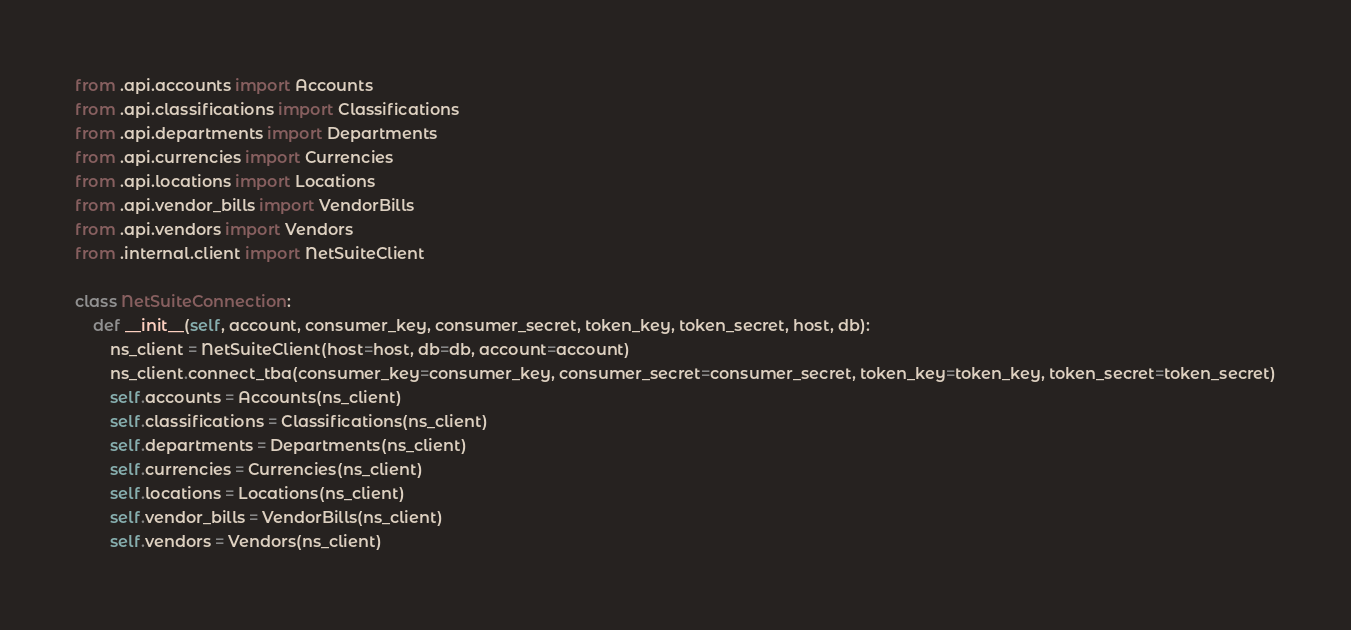<code> <loc_0><loc_0><loc_500><loc_500><_Python_>from .api.accounts import Accounts
from .api.classifications import Classifications
from .api.departments import Departments
from .api.currencies import Currencies
from .api.locations import Locations
from .api.vendor_bills import VendorBills
from .api.vendors import Vendors
from .internal.client import NetSuiteClient

class NetSuiteConnection:
    def __init__(self, account, consumer_key, consumer_secret, token_key, token_secret, host, db):
        ns_client = NetSuiteClient(host=host, db=db, account=account)
        ns_client.connect_tba(consumer_key=consumer_key, consumer_secret=consumer_secret, token_key=token_key, token_secret=token_secret)
        self.accounts = Accounts(ns_client)
        self.classifications = Classifications(ns_client)
        self.departments = Departments(ns_client)
        self.currencies = Currencies(ns_client)
        self.locations = Locations(ns_client)
        self.vendor_bills = VendorBills(ns_client)
        self.vendors = Vendors(ns_client)
</code> 